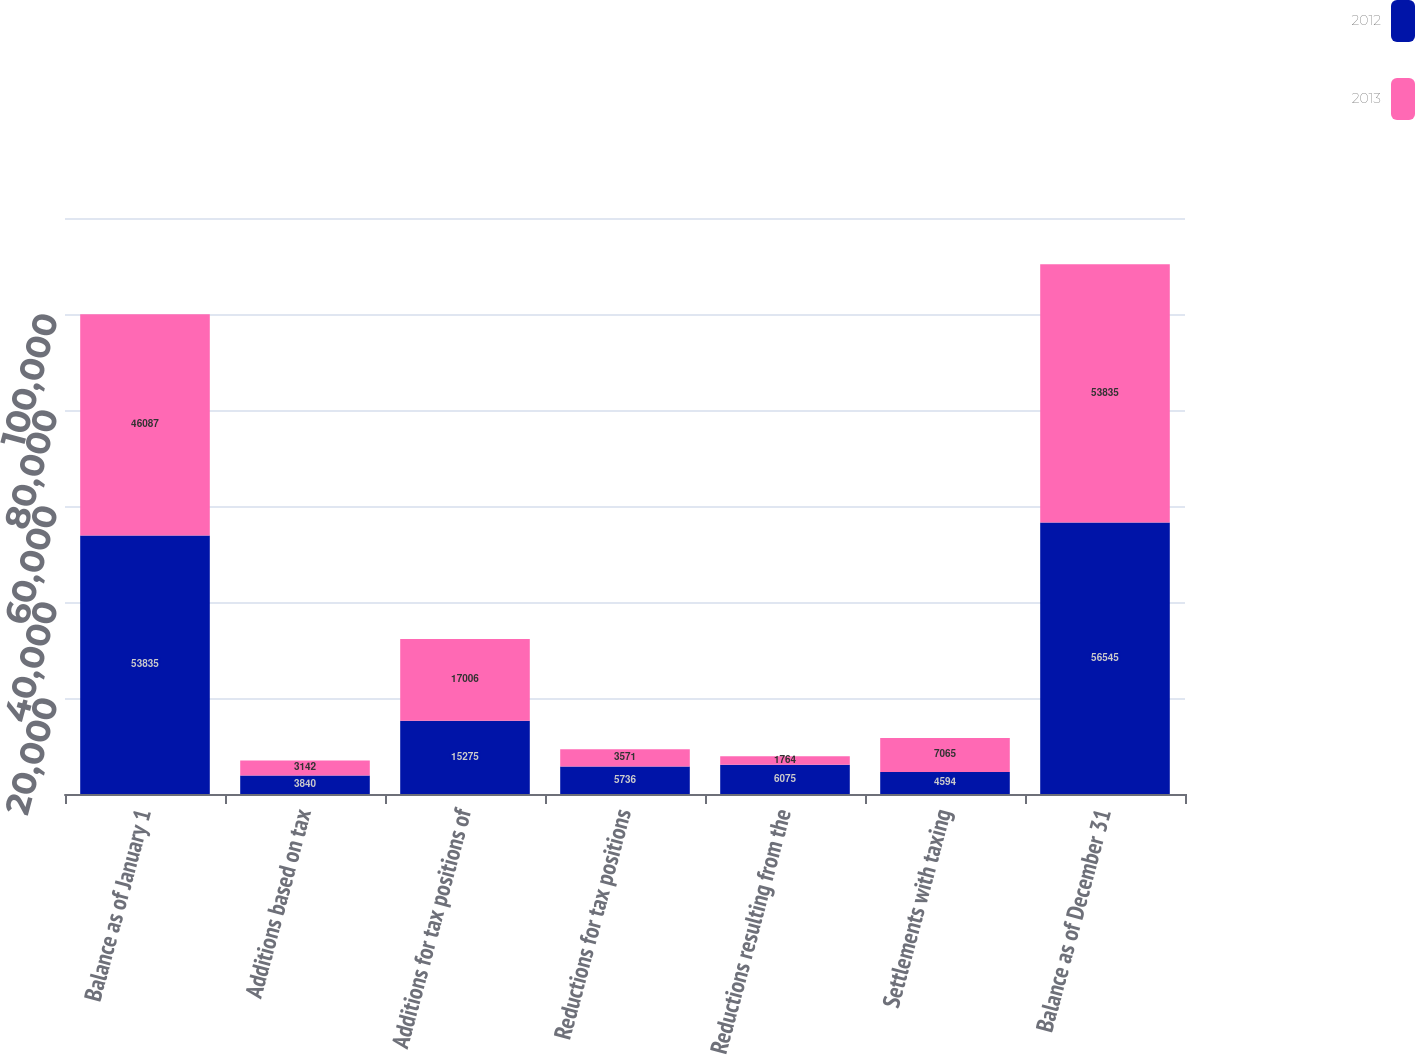Convert chart. <chart><loc_0><loc_0><loc_500><loc_500><stacked_bar_chart><ecel><fcel>Balance as of January 1<fcel>Additions based on tax<fcel>Additions for tax positions of<fcel>Reductions for tax positions<fcel>Reductions resulting from the<fcel>Settlements with taxing<fcel>Balance as of December 31<nl><fcel>2012<fcel>53835<fcel>3840<fcel>15275<fcel>5736<fcel>6075<fcel>4594<fcel>56545<nl><fcel>2013<fcel>46087<fcel>3142<fcel>17006<fcel>3571<fcel>1764<fcel>7065<fcel>53835<nl></chart> 